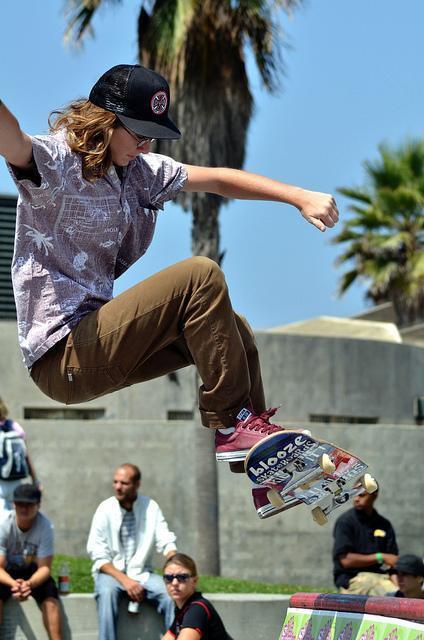In what style park does the skateboarder skate?
Pick the correct solution from the four options below to address the question.
Options: Skate park, state park, store, aviary. Skate park. 